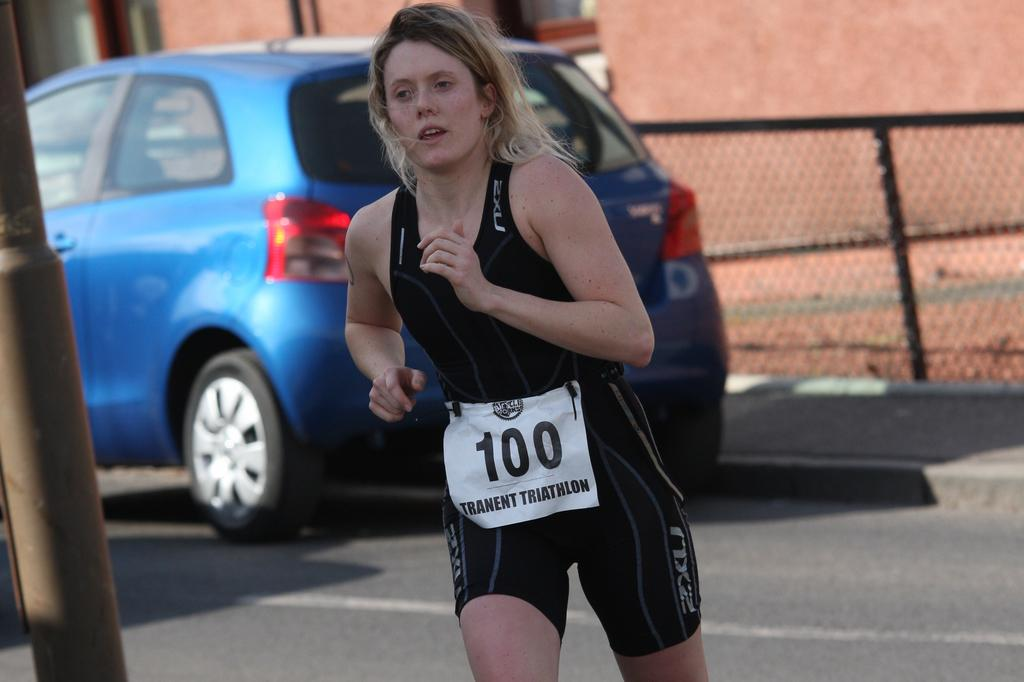Who is the main subject in the image? There is a lady in the image. What can be seen in the background of the image? There is a car, a fence, a building, a road, and other objects in the background of the image. Can you describe the pole on the left side of the image? There is a pole on the left side of the image. How many stars can be seen in the image? There are no stars visible in the image. What type of eggnog is being served in the image? There is no eggnog present in the image. 